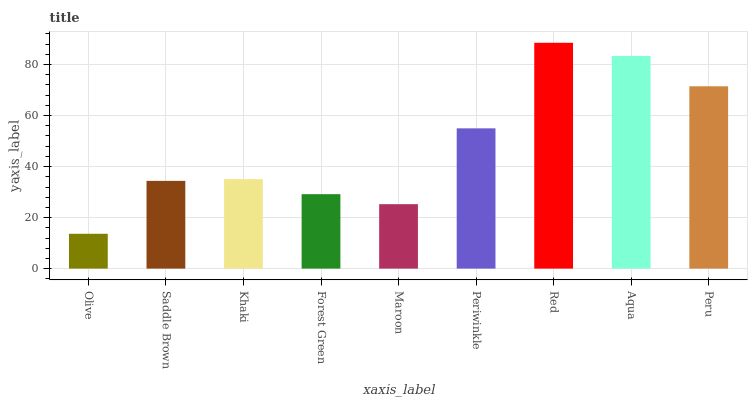Is Olive the minimum?
Answer yes or no. Yes. Is Red the maximum?
Answer yes or no. Yes. Is Saddle Brown the minimum?
Answer yes or no. No. Is Saddle Brown the maximum?
Answer yes or no. No. Is Saddle Brown greater than Olive?
Answer yes or no. Yes. Is Olive less than Saddle Brown?
Answer yes or no. Yes. Is Olive greater than Saddle Brown?
Answer yes or no. No. Is Saddle Brown less than Olive?
Answer yes or no. No. Is Khaki the high median?
Answer yes or no. Yes. Is Khaki the low median?
Answer yes or no. Yes. Is Olive the high median?
Answer yes or no. No. Is Saddle Brown the low median?
Answer yes or no. No. 